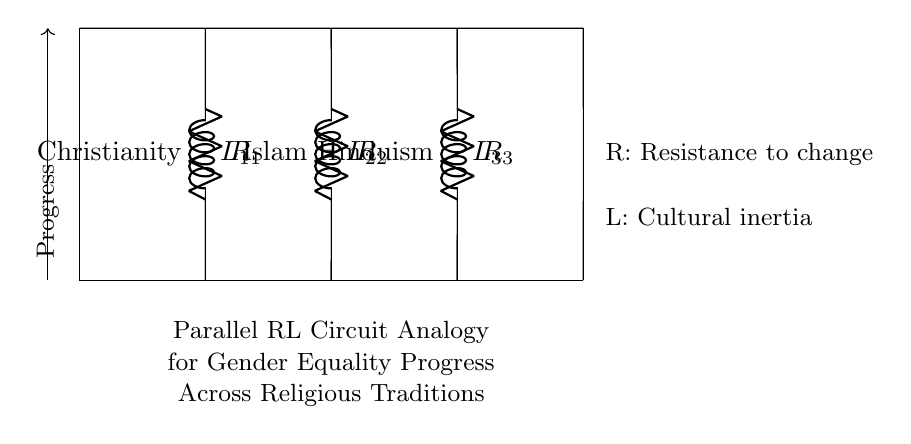What types of components are included in this circuit? The circuit includes resistors and inductors, indicated by the symbols used (R for resistors and L for inductors).
Answer: resistors and inductors How many religious traditions are represented in this circuit? The circuit shows three branches, each labeled with a different religious tradition: Christianity, Islam, and Hinduism.
Answer: three What does "R" represent in this analogy? "R" stands for resistance to change, illustrating how cultural factors impede progress toward gender equality within each tradition.
Answer: resistance to change What does "L" symbolize in the context of this circuit? "L" represents cultural inertia, indicating the lingering cultural factors that sustain inequality and slow progress in gender equality within each religion.
Answer: cultural inertia Which religious tradition has the first resistor-inductor pair? The first pair corresponds to Christianity, as it's labeled on the leftmost section of the circuit diagram.
Answer: Christianity If resistance increases, what happens to the progress in this analogy? An increase in resistance implies a greater barrier to change, which would slow down the progress toward gender equality.
Answer: slows down Why might this circuit analogy be useful for comparing gender equality across religions? This analogy visually represents how differing levels of resistance and cultural inertia impact progress in gender equality, making it easier to compare and analyze the situations across traditions.
Answer: comparative analysis 